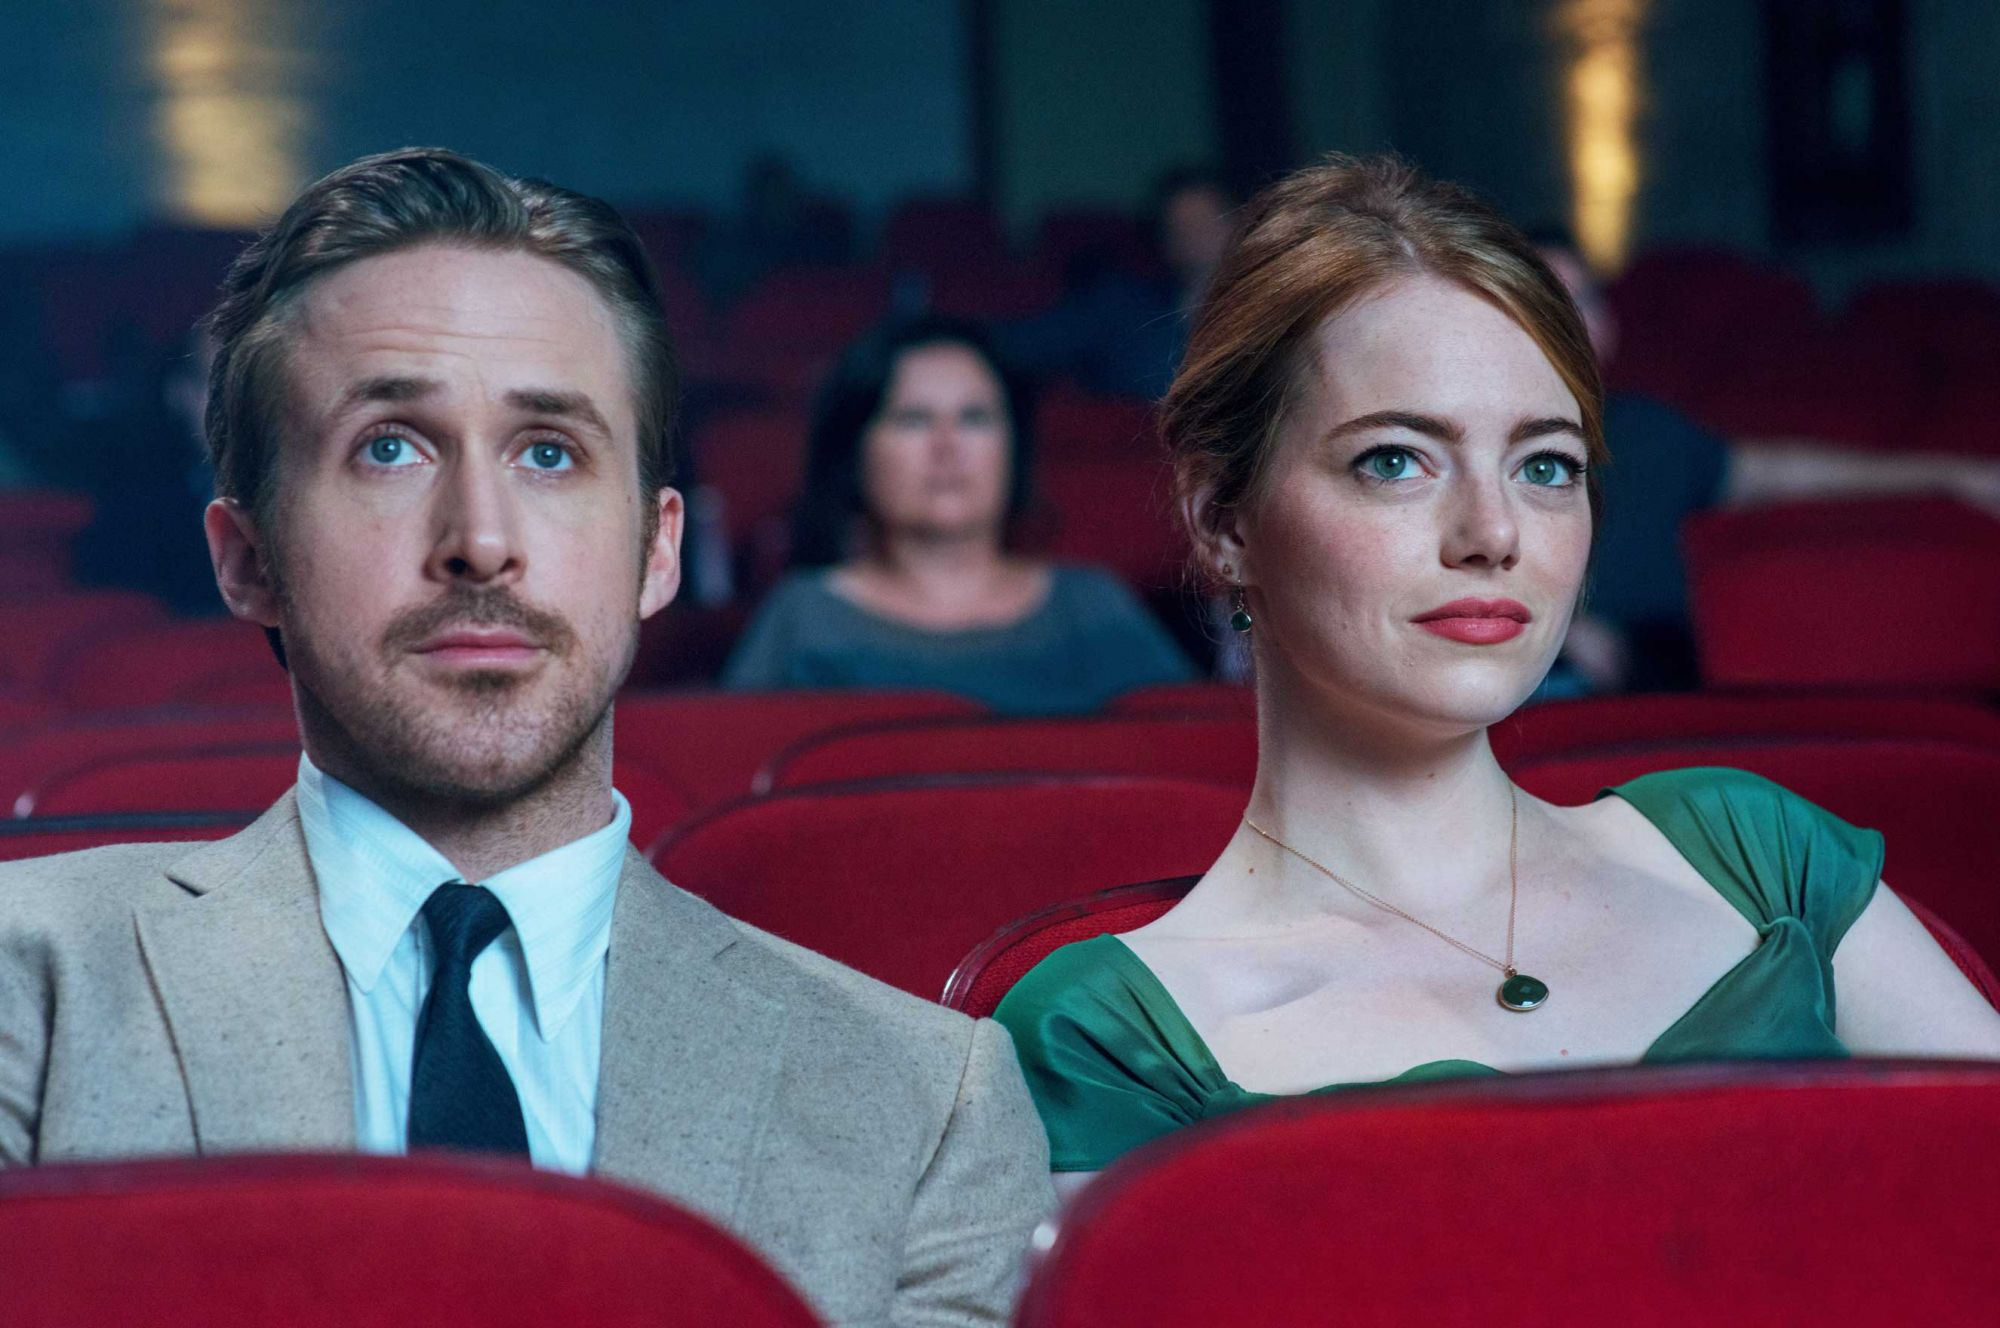Can you describe the main features of this image for me? This image captures a scene from the movie La La Land, featuring the characters Sebastian and Mia, played by Ryan Gosling and Emma Stone. They are seated in a movie theater, with Ryan on the left in a beige suit and Emma on the right in a green dress. Both characters look up at the screen with a mixture of concentration and intrigue, reflecting the film’s immersive storytelling. The red theater seats and the blurred background of other audience members help keep the focus on the two main characters, creating a sense of shared cinema experience. 